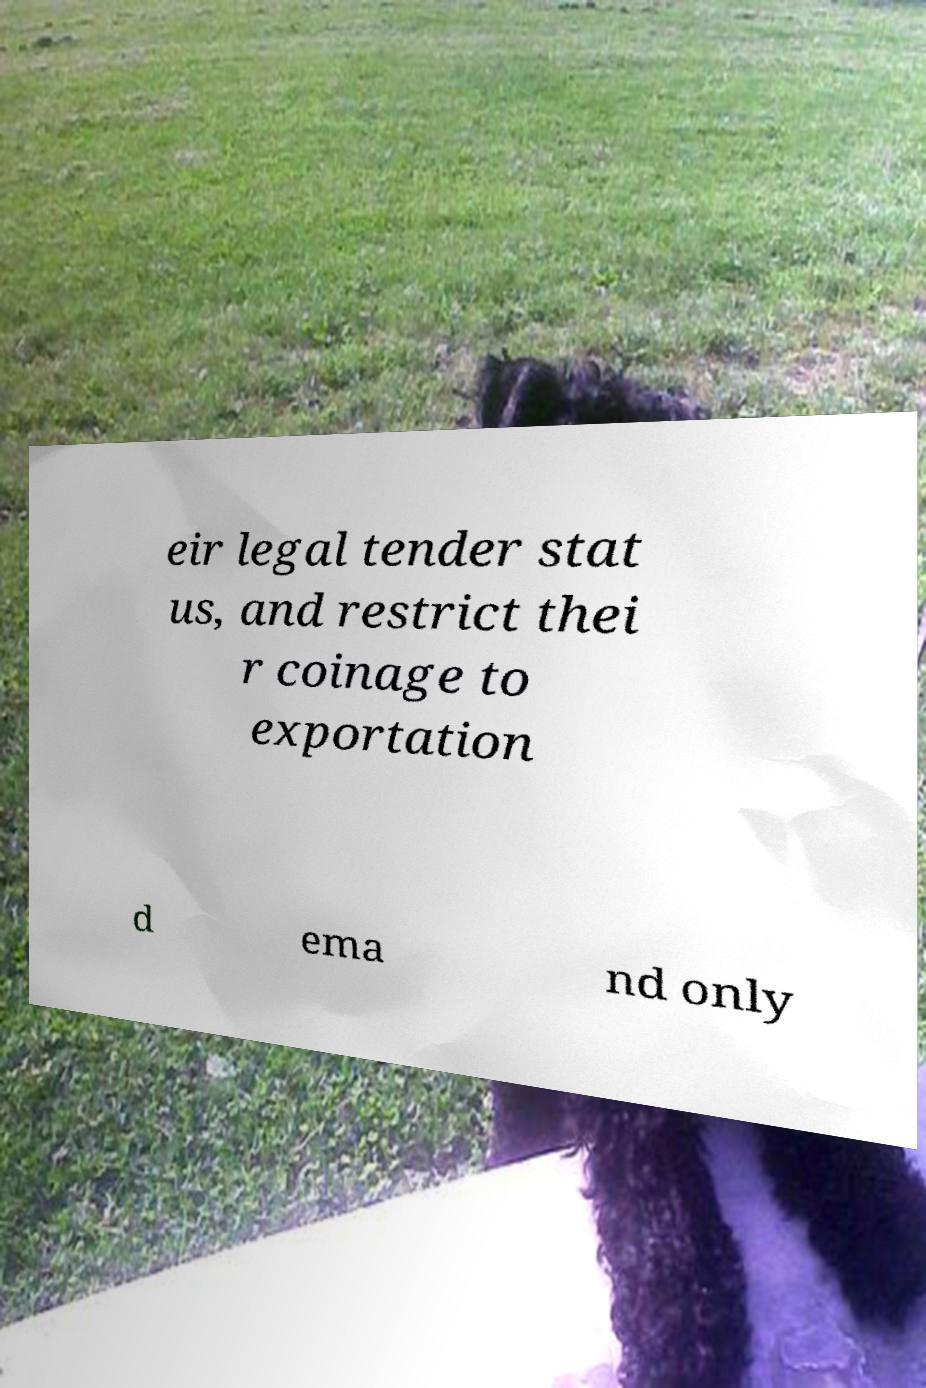For documentation purposes, I need the text within this image transcribed. Could you provide that? eir legal tender stat us, and restrict thei r coinage to exportation d ema nd only 